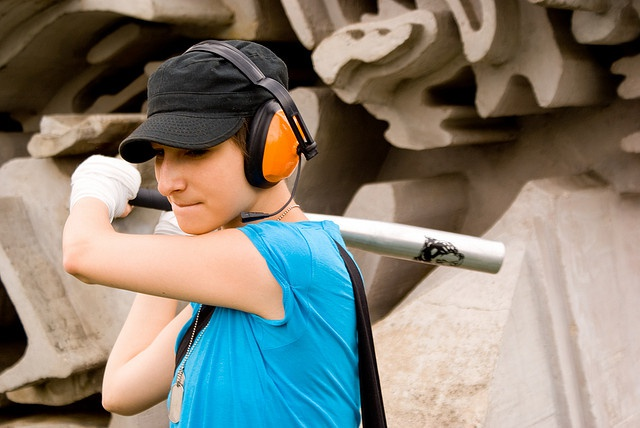Describe the objects in this image and their specific colors. I can see people in black, lightblue, lightgray, and tan tones and baseball bat in black, white, gray, and darkgray tones in this image. 